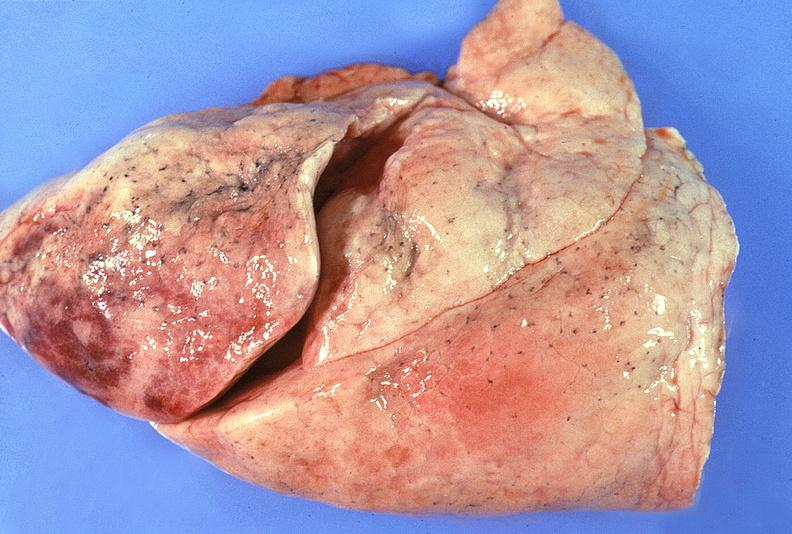s respiratory present?
Answer the question using a single word or phrase. Yes 